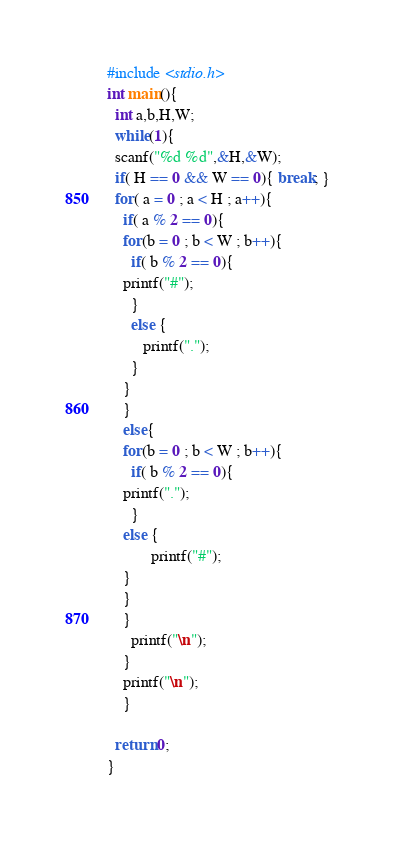<code> <loc_0><loc_0><loc_500><loc_500><_C_>#include <stdio.h>
int main(){
  int a,b,H,W;
  while(1){
  scanf("%d %d",&H,&W);
  if( H == 0 && W == 0){ break; }
  for( a = 0 ; a < H ; a++){
    if( a % 2 == 0){
    for(b = 0 ; b < W ; b++){
      if( b % 2 == 0){
	printf("#");
      }
      else {
         printf(".");
      }
    }
    }
	else{
    for(b = 0 ; b < W ; b++){
      if( b % 2 == 0){
	printf(".");
      }
	else {
           printf("#");
	}
	}
    }
      printf("\n");
    }
    printf("\n");
    }

  return 0;
}</code> 